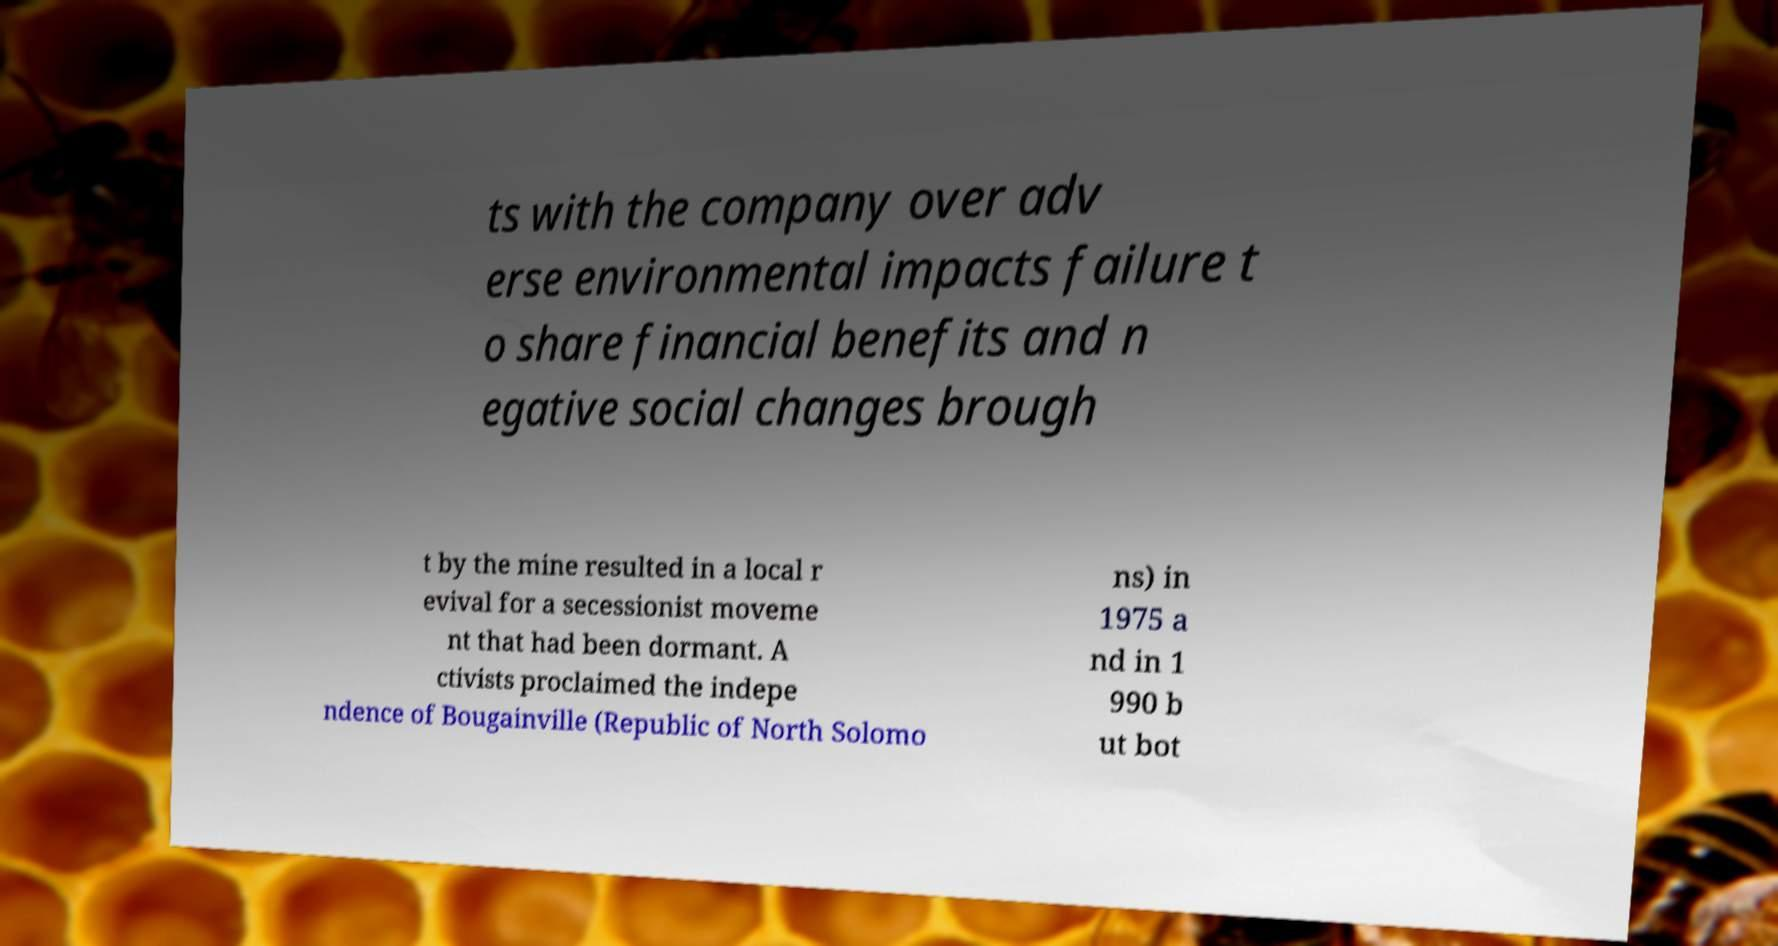Could you assist in decoding the text presented in this image and type it out clearly? ts with the company over adv erse environmental impacts failure t o share financial benefits and n egative social changes brough t by the mine resulted in a local r evival for a secessionist moveme nt that had been dormant. A ctivists proclaimed the indepe ndence of Bougainville (Republic of North Solomo ns) in 1975 a nd in 1 990 b ut bot 